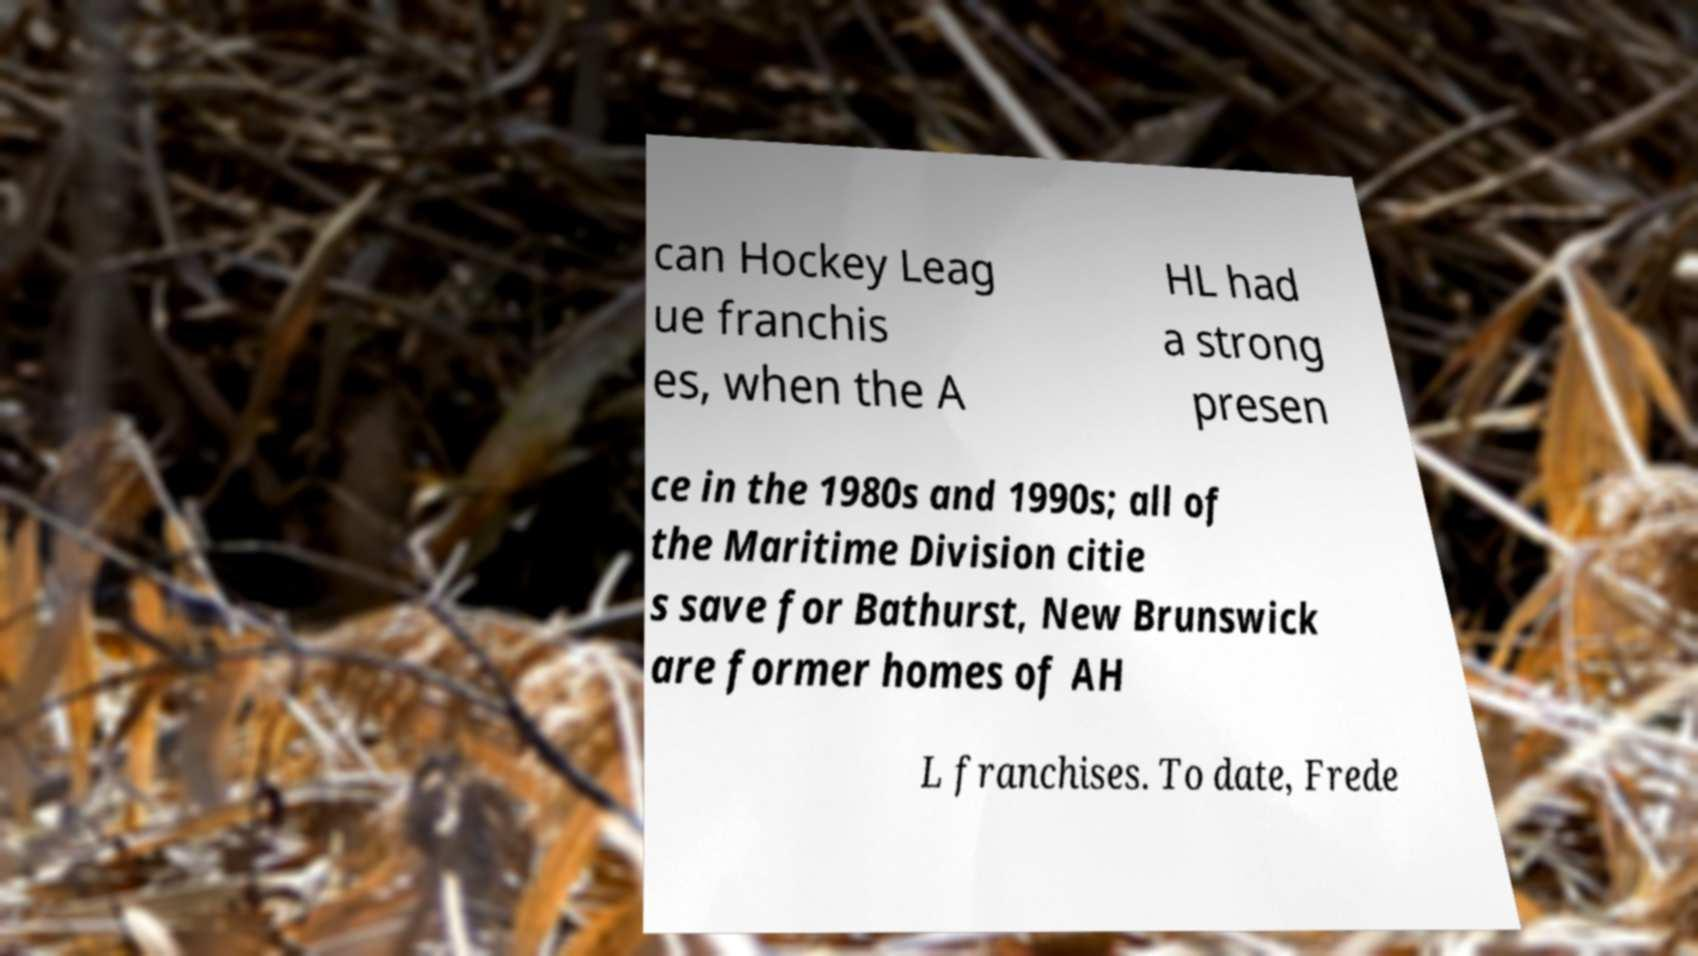What messages or text are displayed in this image? I need them in a readable, typed format. can Hockey Leag ue franchis es, when the A HL had a strong presen ce in the 1980s and 1990s; all of the Maritime Division citie s save for Bathurst, New Brunswick are former homes of AH L franchises. To date, Frede 